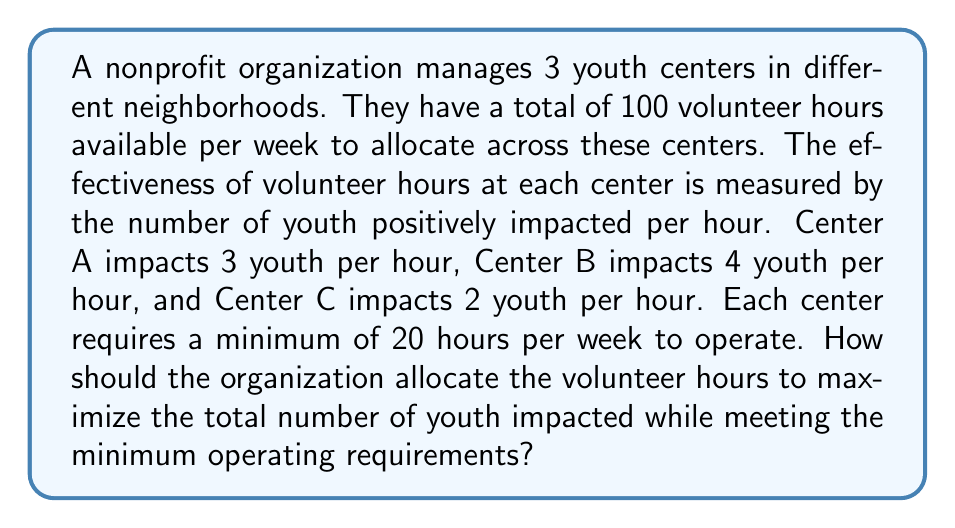Could you help me with this problem? Let's approach this problem using linear programming:

1. Define variables:
   Let $x_A$, $x_B$, and $x_C$ be the number of hours allocated to Centers A, B, and C respectively.

2. Objective function:
   Maximize $Z = 3x_A + 4x_B + 2x_C$

3. Constraints:
   $x_A + x_B + x_C \leq 100$ (total available hours)
   $x_A \geq 20$, $x_B \geq 20$, $x_C \geq 20$ (minimum operating hours)
   $x_A, x_B, x_C \geq 0$ (non-negativity)

4. Solve using the simplex method or graphical method:
   The optimal solution will allocate more hours to Center B as it has the highest impact per hour.

5. Optimal allocation:
   Center A: 20 hours (minimum required)
   Center B: 60 hours
   Center C: 20 hours (minimum required)

6. Calculate maximum impact:
   $Z = 3(20) + 4(60) + 2(20) = 60 + 240 + 40 = 340$ youth impacted

Therefore, the optimal allocation is 20 hours to Center A, 60 hours to Center B, and 20 hours to Center C, which will impact a maximum of 340 youth per week.
Answer: Center A: 20 hours, Center B: 60 hours, Center C: 20 hours 